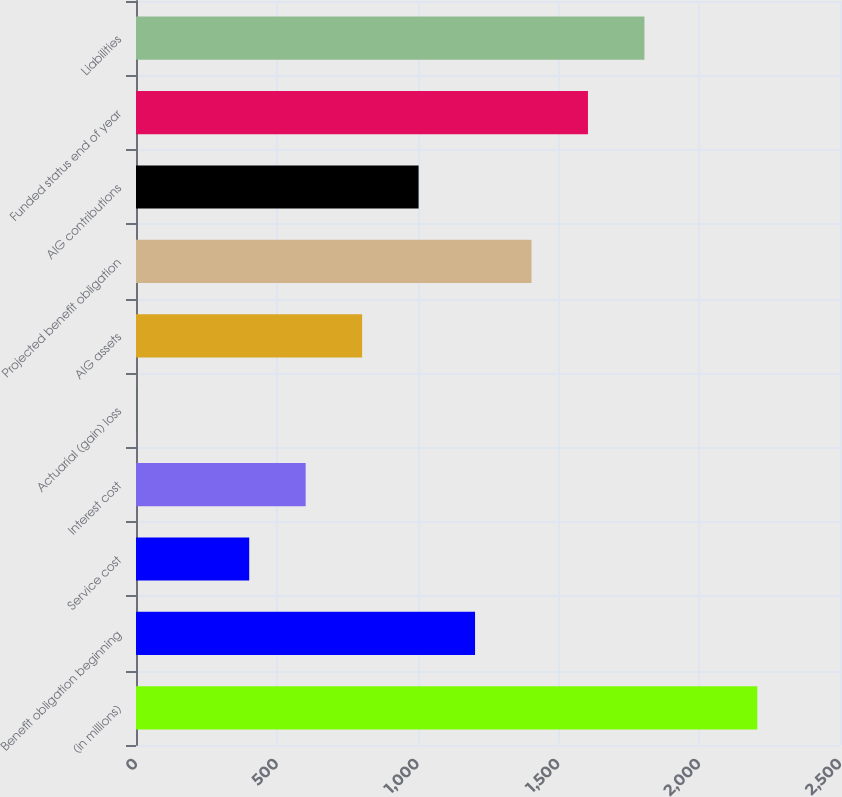Convert chart to OTSL. <chart><loc_0><loc_0><loc_500><loc_500><bar_chart><fcel>(in millions)<fcel>Benefit obligation beginning<fcel>Service cost<fcel>Interest cost<fcel>Actuarial (gain) loss<fcel>AIG assets<fcel>Projected benefit obligation<fcel>AIG contributions<fcel>Funded status end of year<fcel>Liabilities<nl><fcel>2206.5<fcel>1204<fcel>402<fcel>602.5<fcel>1<fcel>803<fcel>1404.5<fcel>1003.5<fcel>1605<fcel>1805.5<nl></chart> 